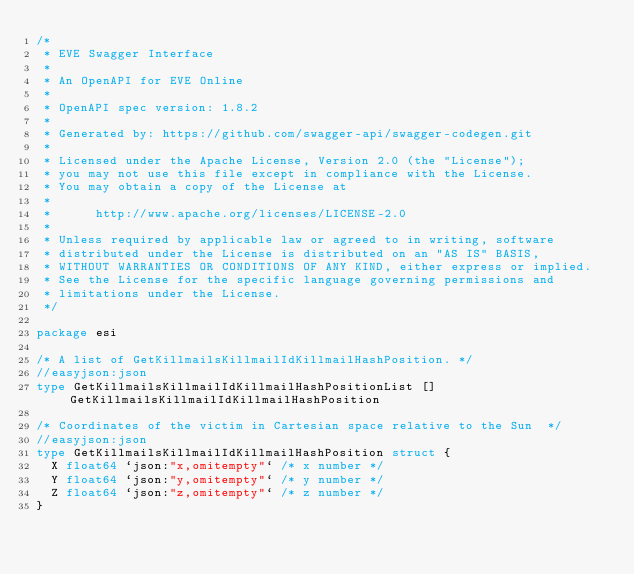<code> <loc_0><loc_0><loc_500><loc_500><_Go_>/*
 * EVE Swagger Interface
 *
 * An OpenAPI for EVE Online
 *
 * OpenAPI spec version: 1.8.2
 *
 * Generated by: https://github.com/swagger-api/swagger-codegen.git
 *
 * Licensed under the Apache License, Version 2.0 (the "License");
 * you may not use this file except in compliance with the License.
 * You may obtain a copy of the License at
 *
 *      http://www.apache.org/licenses/LICENSE-2.0
 *
 * Unless required by applicable law or agreed to in writing, software
 * distributed under the License is distributed on an "AS IS" BASIS,
 * WITHOUT WARRANTIES OR CONDITIONS OF ANY KIND, either express or implied.
 * See the License for the specific language governing permissions and
 * limitations under the License.
 */

package esi

/* A list of GetKillmailsKillmailIdKillmailHashPosition. */
//easyjson:json
type GetKillmailsKillmailIdKillmailHashPositionList []GetKillmailsKillmailIdKillmailHashPosition

/* Coordinates of the victim in Cartesian space relative to the Sun  */
//easyjson:json
type GetKillmailsKillmailIdKillmailHashPosition struct {
	X float64 `json:"x,omitempty"` /* x number */
	Y float64 `json:"y,omitempty"` /* y number */
	Z float64 `json:"z,omitempty"` /* z number */
}
</code> 